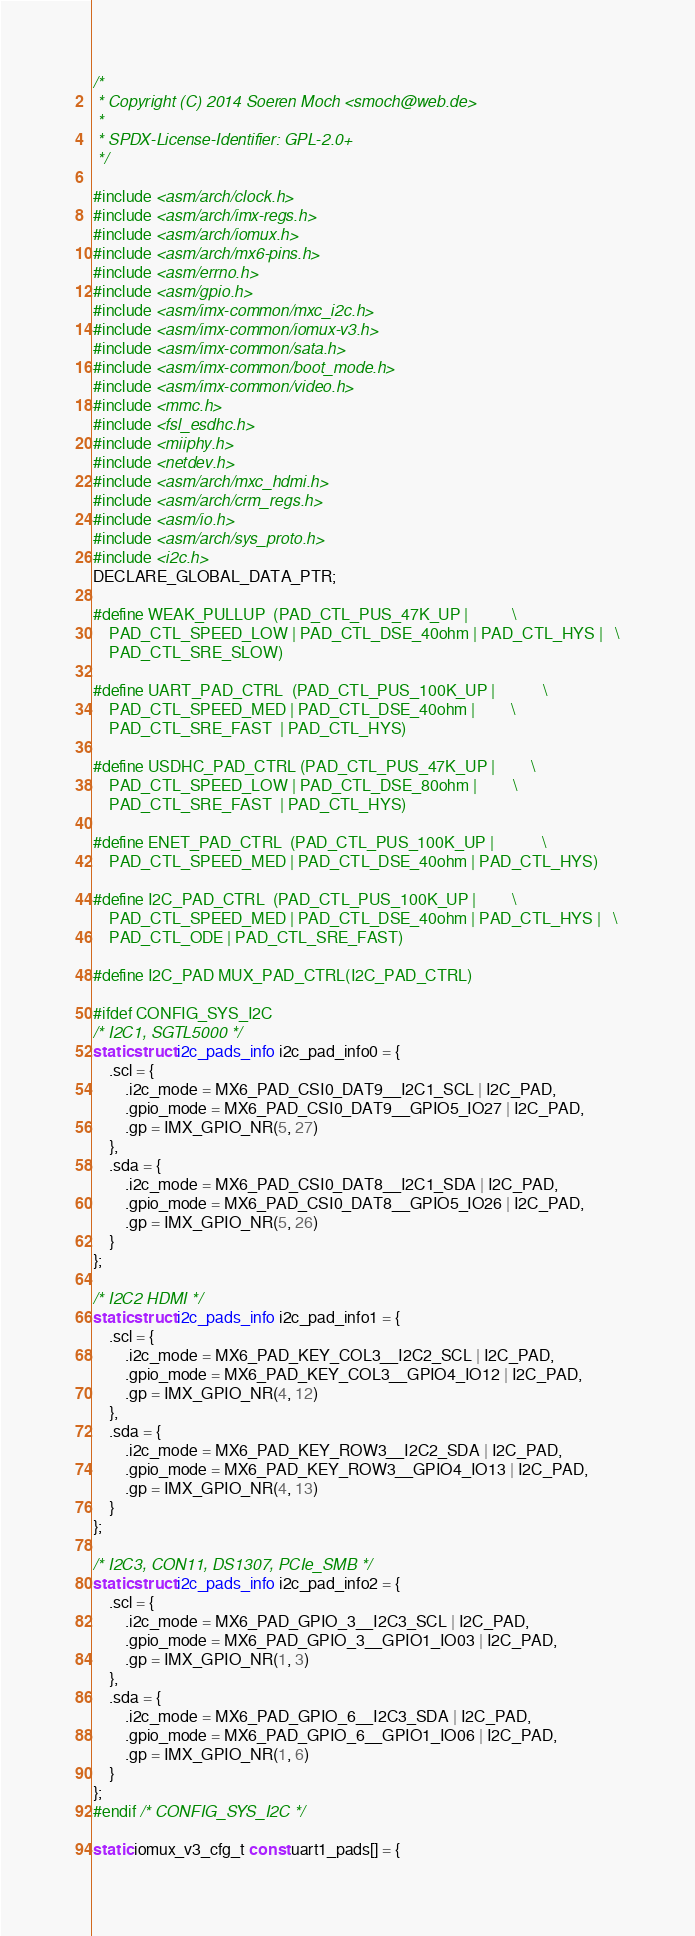Convert code to text. <code><loc_0><loc_0><loc_500><loc_500><_C_>/*
 * Copyright (C) 2014 Soeren Moch <smoch@web.de>
 *
 * SPDX-License-Identifier:	GPL-2.0+
 */

#include <asm/arch/clock.h>
#include <asm/arch/imx-regs.h>
#include <asm/arch/iomux.h>
#include <asm/arch/mx6-pins.h>
#include <asm/errno.h>
#include <asm/gpio.h>
#include <asm/imx-common/mxc_i2c.h>
#include <asm/imx-common/iomux-v3.h>
#include <asm/imx-common/sata.h>
#include <asm/imx-common/boot_mode.h>
#include <asm/imx-common/video.h>
#include <mmc.h>
#include <fsl_esdhc.h>
#include <miiphy.h>
#include <netdev.h>
#include <asm/arch/mxc_hdmi.h>
#include <asm/arch/crm_regs.h>
#include <asm/io.h>
#include <asm/arch/sys_proto.h>
#include <i2c.h>
DECLARE_GLOBAL_DATA_PTR;

#define WEAK_PULLUP	(PAD_CTL_PUS_47K_UP |			\
	PAD_CTL_SPEED_LOW | PAD_CTL_DSE_40ohm | PAD_CTL_HYS |	\
	PAD_CTL_SRE_SLOW)

#define UART_PAD_CTRL  (PAD_CTL_PUS_100K_UP |			\
	PAD_CTL_SPEED_MED | PAD_CTL_DSE_40ohm |			\
	PAD_CTL_SRE_FAST  | PAD_CTL_HYS)

#define USDHC_PAD_CTRL (PAD_CTL_PUS_47K_UP |			\
	PAD_CTL_SPEED_LOW | PAD_CTL_DSE_80ohm |			\
	PAD_CTL_SRE_FAST  | PAD_CTL_HYS)

#define ENET_PAD_CTRL  (PAD_CTL_PUS_100K_UP |			\
	PAD_CTL_SPEED_MED | PAD_CTL_DSE_40ohm | PAD_CTL_HYS)

#define I2C_PAD_CTRL  (PAD_CTL_PUS_100K_UP |			\
	PAD_CTL_SPEED_MED | PAD_CTL_DSE_40ohm | PAD_CTL_HYS |	\
	PAD_CTL_ODE | PAD_CTL_SRE_FAST)

#define I2C_PAD MUX_PAD_CTRL(I2C_PAD_CTRL)

#ifdef CONFIG_SYS_I2C
/* I2C1, SGTL5000 */
static struct i2c_pads_info i2c_pad_info0 = {
	.scl = {
		.i2c_mode = MX6_PAD_CSI0_DAT9__I2C1_SCL | I2C_PAD,
		.gpio_mode = MX6_PAD_CSI0_DAT9__GPIO5_IO27 | I2C_PAD,
		.gp = IMX_GPIO_NR(5, 27)
	},
	.sda = {
		.i2c_mode = MX6_PAD_CSI0_DAT8__I2C1_SDA | I2C_PAD,
		.gpio_mode = MX6_PAD_CSI0_DAT8__GPIO5_IO26 | I2C_PAD,
		.gp = IMX_GPIO_NR(5, 26)
	}
};

/* I2C2 HDMI */
static struct i2c_pads_info i2c_pad_info1 = {
	.scl = {
		.i2c_mode = MX6_PAD_KEY_COL3__I2C2_SCL | I2C_PAD,
		.gpio_mode = MX6_PAD_KEY_COL3__GPIO4_IO12 | I2C_PAD,
		.gp = IMX_GPIO_NR(4, 12)
	},
	.sda = {
		.i2c_mode = MX6_PAD_KEY_ROW3__I2C2_SDA | I2C_PAD,
		.gpio_mode = MX6_PAD_KEY_ROW3__GPIO4_IO13 | I2C_PAD,
		.gp = IMX_GPIO_NR(4, 13)
	}
};

/* I2C3, CON11, DS1307, PCIe_SMB */
static struct i2c_pads_info i2c_pad_info2 = {
	.scl = {
		.i2c_mode = MX6_PAD_GPIO_3__I2C3_SCL | I2C_PAD,
		.gpio_mode = MX6_PAD_GPIO_3__GPIO1_IO03 | I2C_PAD,
		.gp = IMX_GPIO_NR(1, 3)
	},
	.sda = {
		.i2c_mode = MX6_PAD_GPIO_6__I2C3_SDA | I2C_PAD,
		.gpio_mode = MX6_PAD_GPIO_6__GPIO1_IO06 | I2C_PAD,
		.gp = IMX_GPIO_NR(1, 6)
	}
};
#endif /* CONFIG_SYS_I2C */

static iomux_v3_cfg_t const uart1_pads[] = {</code> 